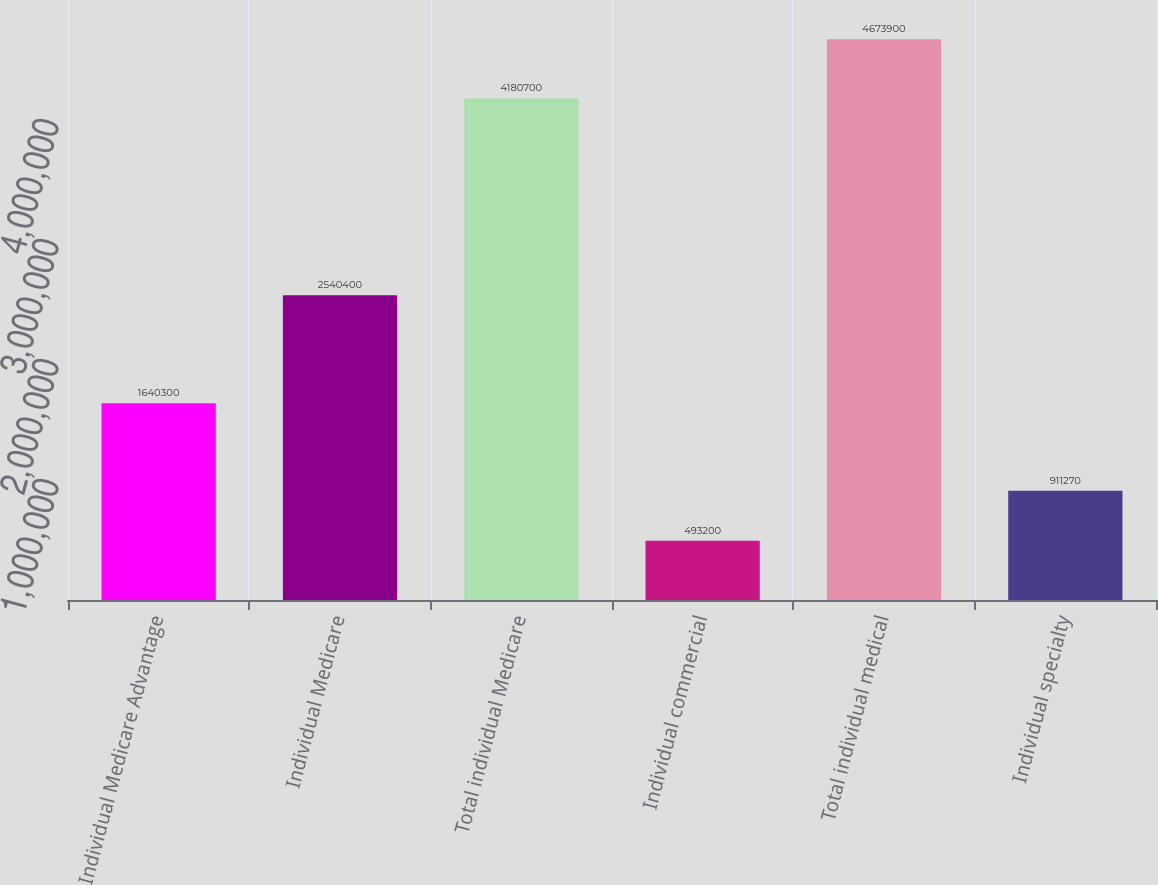Convert chart to OTSL. <chart><loc_0><loc_0><loc_500><loc_500><bar_chart><fcel>Individual Medicare Advantage<fcel>Individual Medicare<fcel>Total individual Medicare<fcel>Individual commercial<fcel>Total individual medical<fcel>Individual specialty<nl><fcel>1.6403e+06<fcel>2.5404e+06<fcel>4.1807e+06<fcel>493200<fcel>4.6739e+06<fcel>911270<nl></chart> 